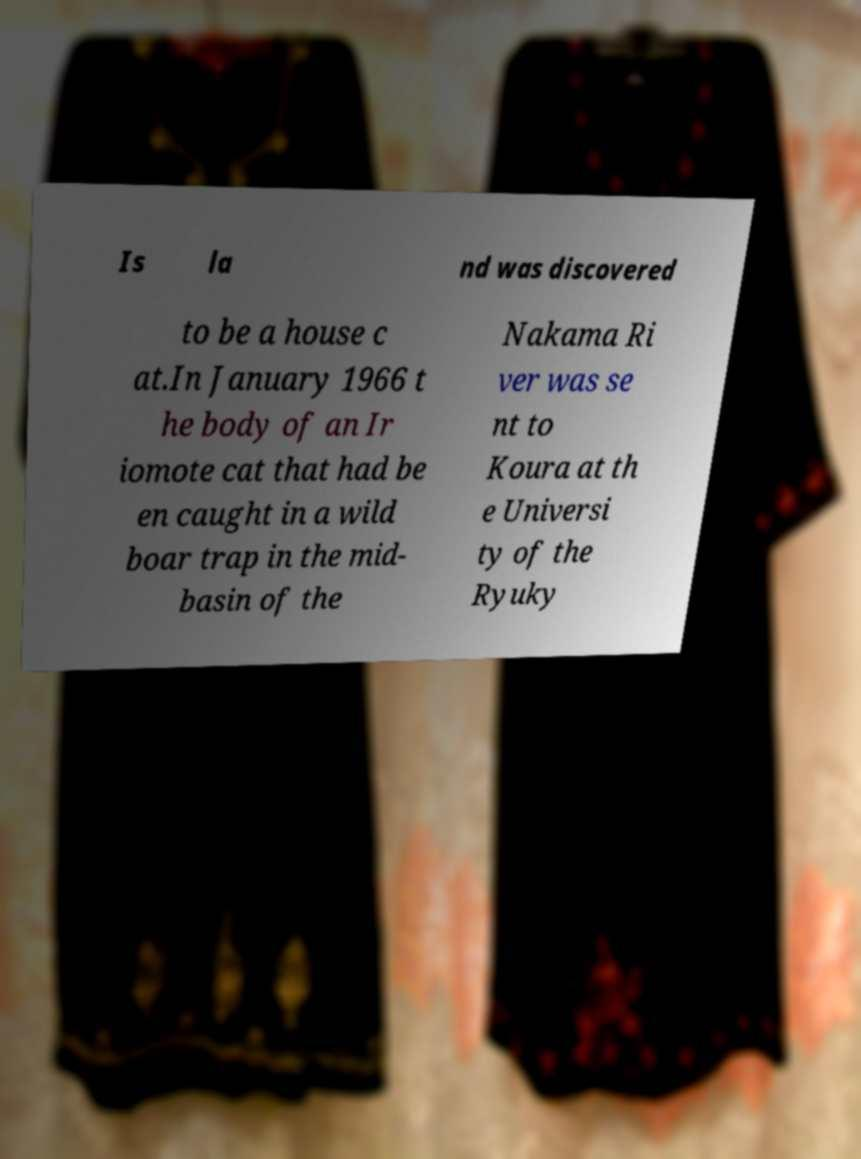Please read and relay the text visible in this image. What does it say? Is la nd was discovered to be a house c at.In January 1966 t he body of an Ir iomote cat that had be en caught in a wild boar trap in the mid- basin of the Nakama Ri ver was se nt to Koura at th e Universi ty of the Ryuky 